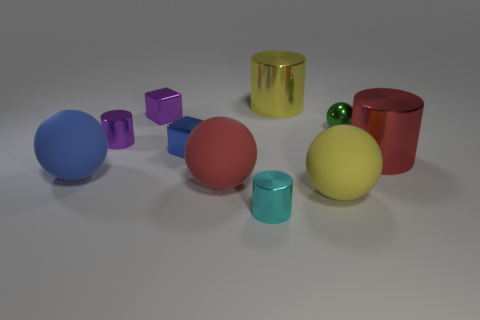What number of other objects are the same material as the large red cylinder?
Ensure brevity in your answer.  6. Do the yellow ball and the purple cube have the same material?
Provide a succinct answer. No. How many other objects are the same size as the yellow metallic thing?
Your response must be concise. 4. What is the size of the red object that is in front of the large object to the right of the large yellow sphere?
Keep it short and to the point. Large. The small cylinder behind the tiny metallic cylinder on the right side of the red thing on the left side of the cyan metallic cylinder is what color?
Provide a short and direct response. Purple. What is the size of the object that is in front of the large red matte sphere and behind the cyan cylinder?
Give a very brief answer. Large. What number of other objects are the same shape as the green metallic thing?
Provide a succinct answer. 3. How many cylinders are either green things or large shiny objects?
Your response must be concise. 2. Is there a small blue cube that is behind the large metallic cylinder to the left of the metallic ball that is behind the tiny cyan shiny thing?
Offer a terse response. No. What is the color of the other thing that is the same shape as the blue metallic thing?
Provide a succinct answer. Purple. 